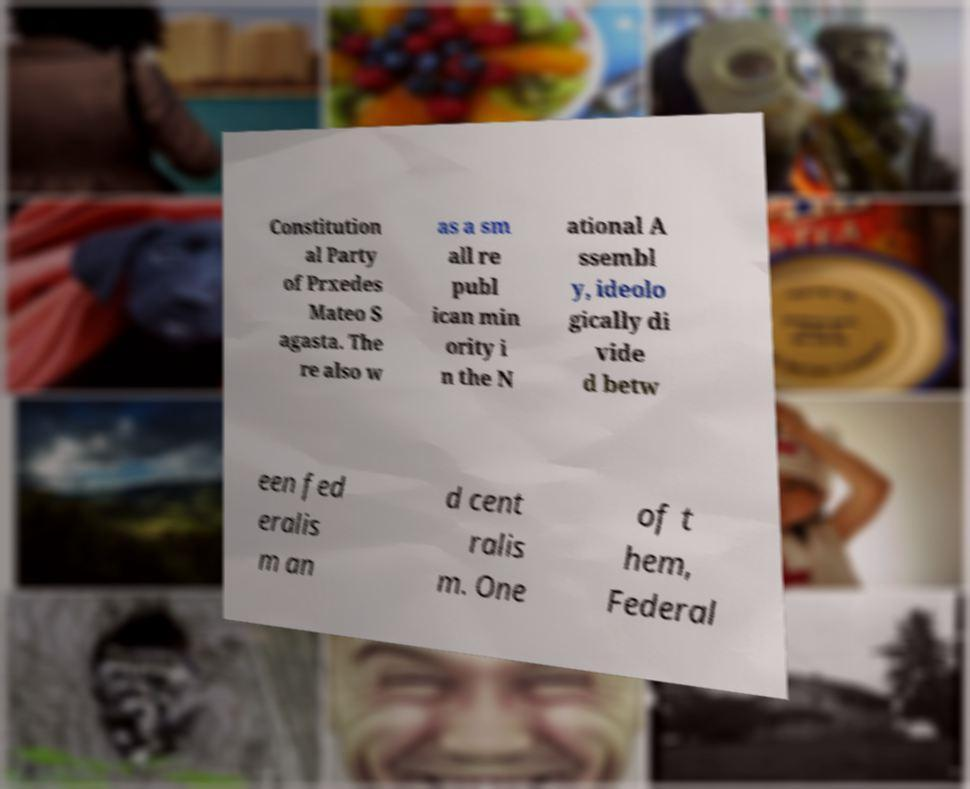Can you read and provide the text displayed in the image?This photo seems to have some interesting text. Can you extract and type it out for me? Constitution al Party of Prxedes Mateo S agasta. The re also w as a sm all re publ ican min ority i n the N ational A ssembl y, ideolo gically di vide d betw een fed eralis m an d cent ralis m. One of t hem, Federal 